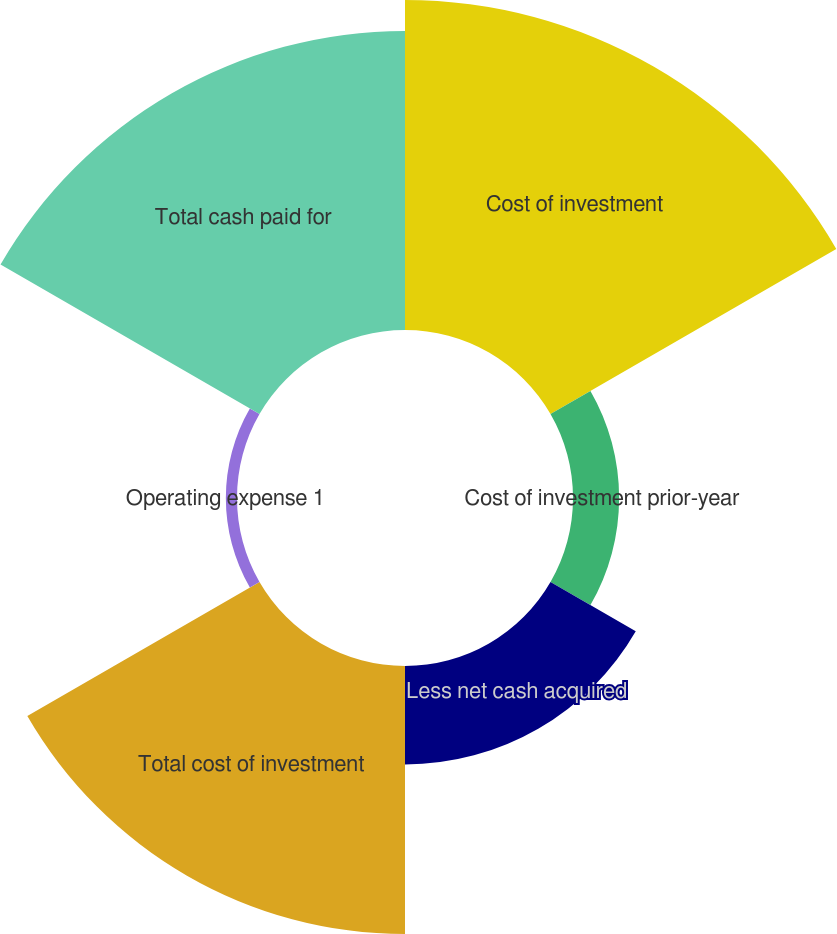Convert chart to OTSL. <chart><loc_0><loc_0><loc_500><loc_500><pie_chart><fcel>Cost of investment<fcel>Cost of investment prior-year<fcel>Less net cash acquired<fcel>Total cost of investment<fcel>Operating expense 1<fcel>Total cash paid for<nl><fcel>31.34%<fcel>4.38%<fcel>9.35%<fcel>25.46%<fcel>1.06%<fcel>28.4%<nl></chart> 